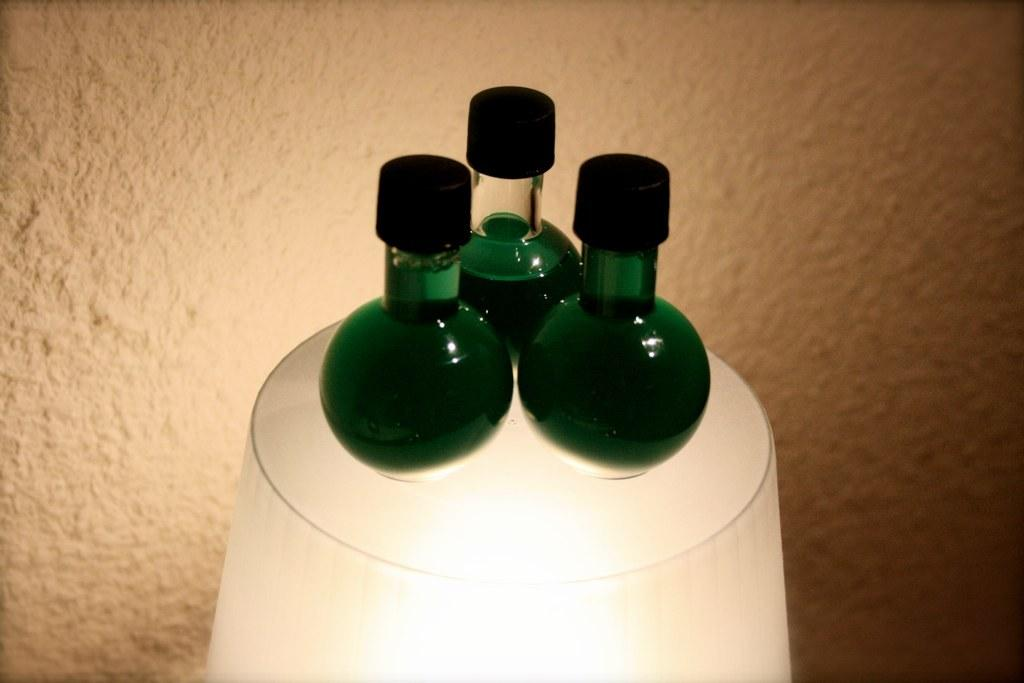What objects are present in the image that have caps? There are three jars with caps in the image. Where are the jars located? The jars are on a lamp. What can be seen in the background of the image? There is a wall visible in the background of the image. How many bells are hanging from the wall in the image? There are no bells present in the image; it only features three jars with caps on a lamp. 